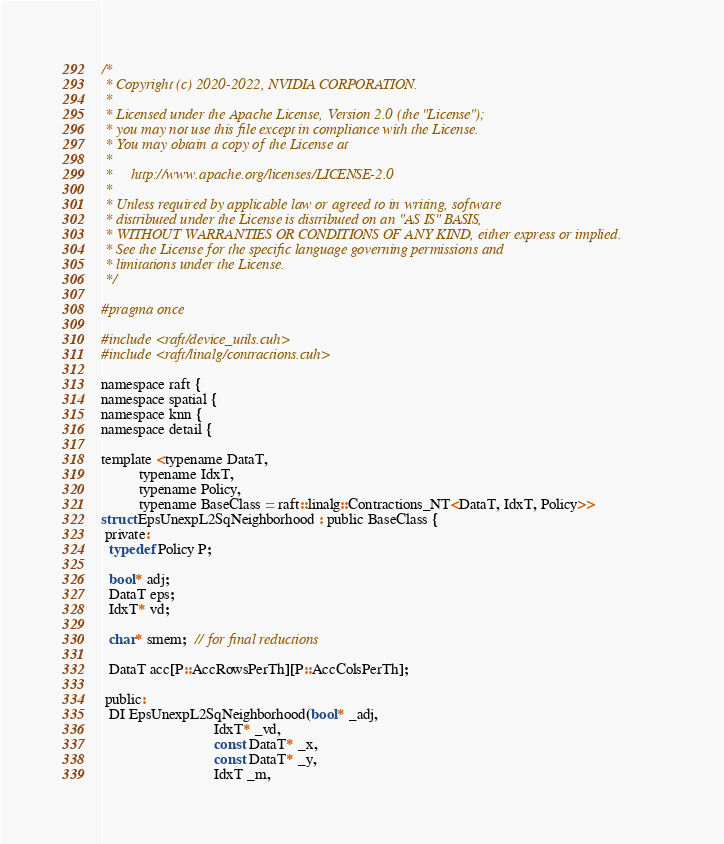<code> <loc_0><loc_0><loc_500><loc_500><_Cuda_>/*
 * Copyright (c) 2020-2022, NVIDIA CORPORATION.
 *
 * Licensed under the Apache License, Version 2.0 (the "License");
 * you may not use this file except in compliance with the License.
 * You may obtain a copy of the License at
 *
 *     http://www.apache.org/licenses/LICENSE-2.0
 *
 * Unless required by applicable law or agreed to in writing, software
 * distributed under the License is distributed on an "AS IS" BASIS,
 * WITHOUT WARRANTIES OR CONDITIONS OF ANY KIND, either express or implied.
 * See the License for the specific language governing permissions and
 * limitations under the License.
 */

#pragma once

#include <raft/device_utils.cuh>
#include <raft/linalg/contractions.cuh>

namespace raft {
namespace spatial {
namespace knn {
namespace detail {

template <typename DataT,
          typename IdxT,
          typename Policy,
          typename BaseClass = raft::linalg::Contractions_NT<DataT, IdxT, Policy>>
struct EpsUnexpL2SqNeighborhood : public BaseClass {
 private:
  typedef Policy P;

  bool* adj;
  DataT eps;
  IdxT* vd;

  char* smem;  // for final reductions

  DataT acc[P::AccRowsPerTh][P::AccColsPerTh];

 public:
  DI EpsUnexpL2SqNeighborhood(bool* _adj,
                              IdxT* _vd,
                              const DataT* _x,
                              const DataT* _y,
                              IdxT _m,</code> 